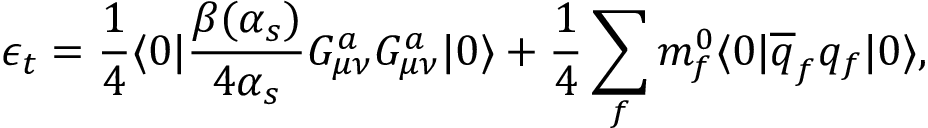<formula> <loc_0><loc_0><loc_500><loc_500>\epsilon _ { t } = { \frac { 1 } { 4 } } \langle { 0 } | { \frac { \beta ( \alpha _ { s } ) } { 4 \alpha _ { s } } } G _ { \mu \nu } ^ { a } G _ { \mu \nu } ^ { a } | { 0 } \rangle + { \frac { 1 } { 4 } } \sum _ { f } m _ { f } ^ { 0 } \langle { 0 } | \overline { q } _ { f } q _ { f } | { 0 } \rangle ,</formula> 